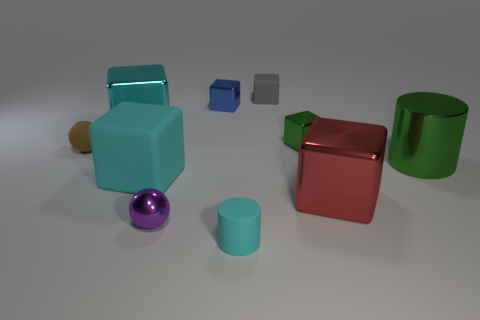How many geometric shapes can you identify in the image? Within the image, I can identify a total of 7 geometric shapes including a variety of cubes, cylinders, and a sphere. 